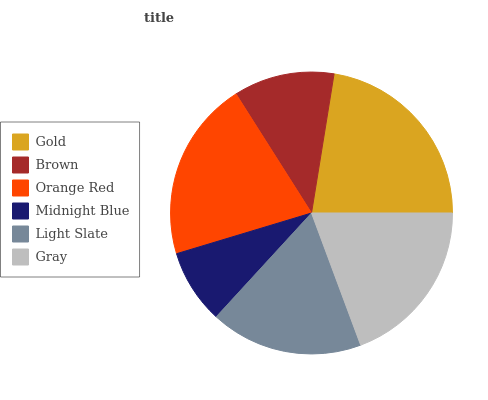Is Midnight Blue the minimum?
Answer yes or no. Yes. Is Gold the maximum?
Answer yes or no. Yes. Is Brown the minimum?
Answer yes or no. No. Is Brown the maximum?
Answer yes or no. No. Is Gold greater than Brown?
Answer yes or no. Yes. Is Brown less than Gold?
Answer yes or no. Yes. Is Brown greater than Gold?
Answer yes or no. No. Is Gold less than Brown?
Answer yes or no. No. Is Gray the high median?
Answer yes or no. Yes. Is Light Slate the low median?
Answer yes or no. Yes. Is Light Slate the high median?
Answer yes or no. No. Is Brown the low median?
Answer yes or no. No. 